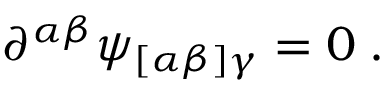<formula> <loc_0><loc_0><loc_500><loc_500>\partial ^ { \alpha \beta } \psi _ { [ \alpha \beta ] \gamma } = 0 \, .</formula> 